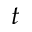<formula> <loc_0><loc_0><loc_500><loc_500>t</formula> 